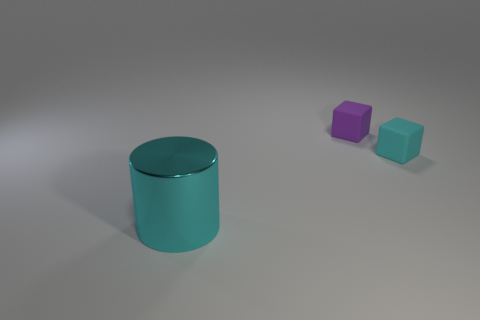What material is the object that is both in front of the tiny purple object and to the right of the large thing? The object in question appears to be a smaller, aqua-colored cube, positioned in front of the tiny purple cube and to the right of the larger cylinder. While I referred to the material as 'rubber' initially, it's important to clarify that, without tactile or additional visual information, we cannot be certain of the material just by the image. However, based on visual cues such as the surface reflection and appearance, we could speculate that the cube may be made of a plastic or polished metal, but this is purely a conjecture. 